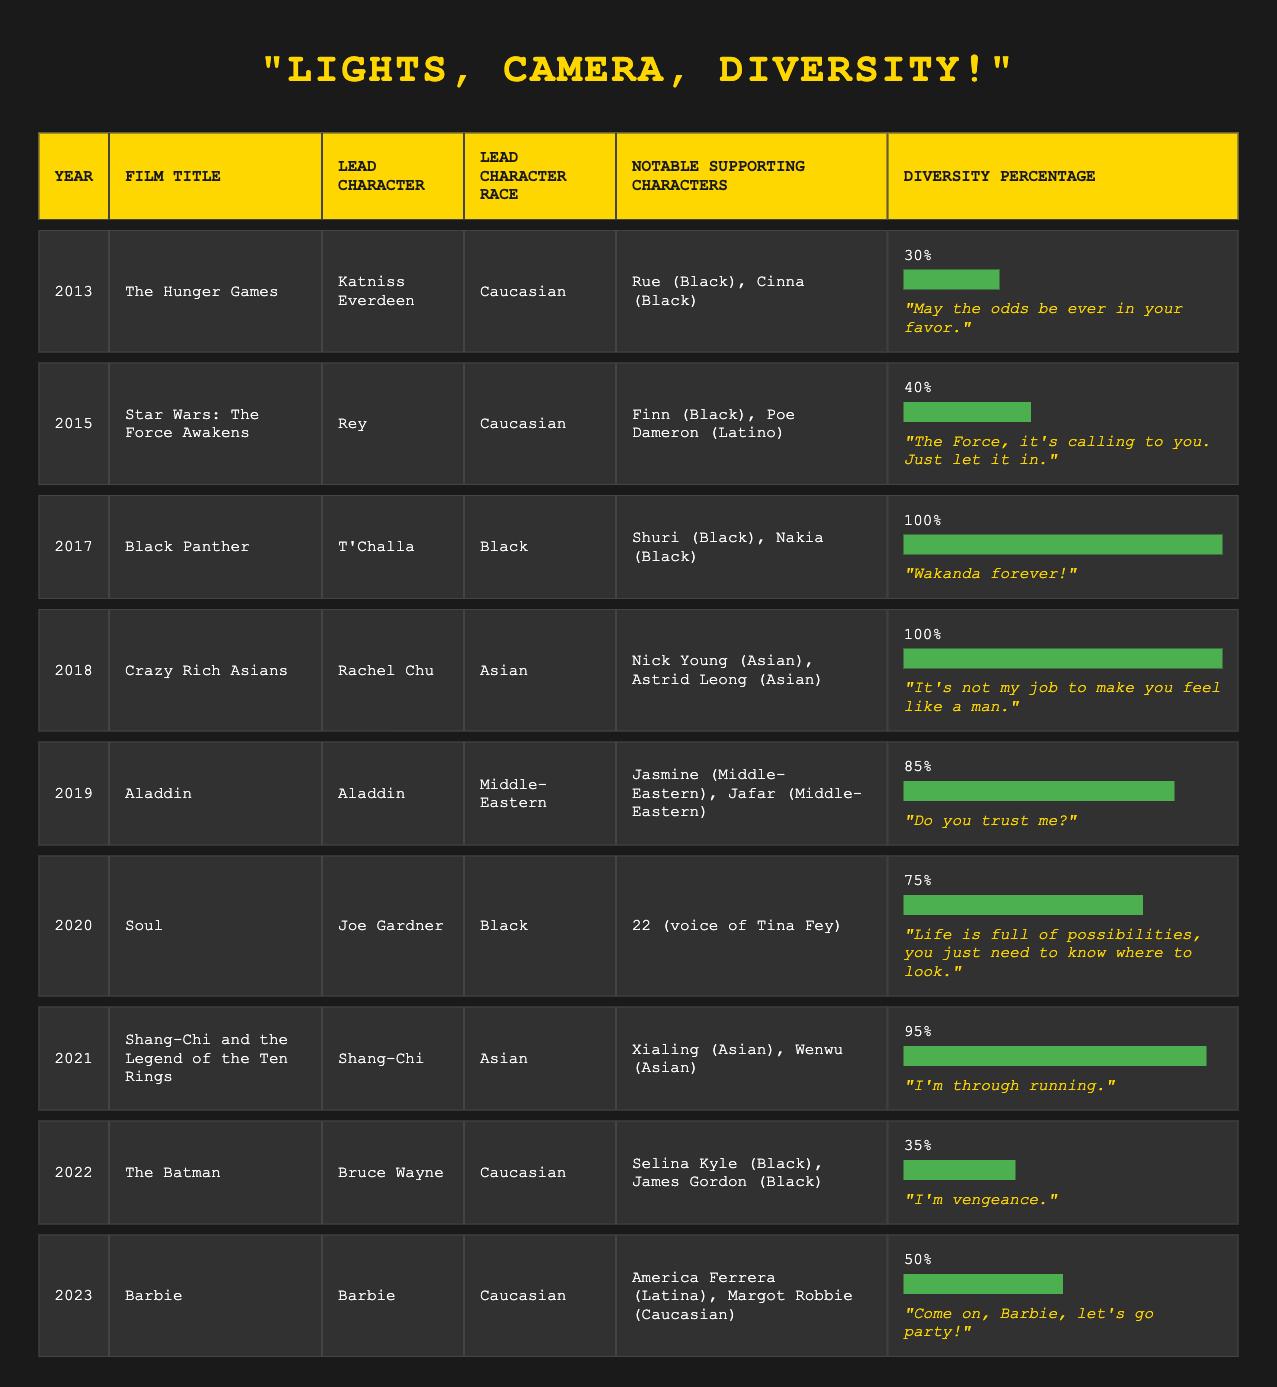What is the diversity percentage of "Black Panther"? From the table, "Black Panther" is listed under the year 2017 and has a diversity percentage of 100%.
Answer: 100% In what year did "Crazy Rich Asians" release? The table lists "Crazy Rich Asians" under the year 2018.
Answer: 2018 Which film had the highest diversity percentage? Looking through the table, both "Black Panther" (2017) and "Crazy Rich Asians" (2018) have a diversity percentage of 100%, which is the highest.
Answer: Black Panther and Crazy Rich Asians What is the average diversity percentage of the films between 2013 and 2018? The diversity percentages from these years are: 30%, 40%, 100%, 100%, 85%, and 75%. Adding them gives 430% and dividing by 6 gives an average of 71.67%.
Answer: 71.67% Did "Aladdin" feature a Caucasian lead character? According to the table, "Aladdin" has the lead character Aladdin who is listed as Middle-Eastern, so the statement is false.
Answer: No What is the total diversity percentage of the films released in 2020 and 2021? The diversity percentages for "Soul" from 2020 is 75% and "Shang-Chi and the Legend of the Ten Rings" from 2021 is 95%. Adding these gives 170%, so the total diversity percentage is 170%.
Answer: 170% How many films had a diversity percentage of 75% or higher? The films with diversity percentages of 75% or higher are "Black Panther," "Crazy Rich Asians," "Aladdin," "Soul," and "Shang-Chi and the Legend of the Ten Rings." There are 5 films in total.
Answer: 5 Which lead character from the table is Asian? From the table, the lead characters who are Asian are Rachel Chu from "Crazy Rich Asians" (2018) and Shang-Chi from "Shang-Chi and the Legend of the Ten Rings" (2021).
Answer: Rachel Chu and Shang-Chi What is the diversity percentage difference between "The Hunger Games" and "Barbie"? "The Hunger Games" has a diversity percentage of 30% and "Barbie" has a diversity percentage of 50%. The difference is 50% - 30% = 20%.
Answer: 20% 